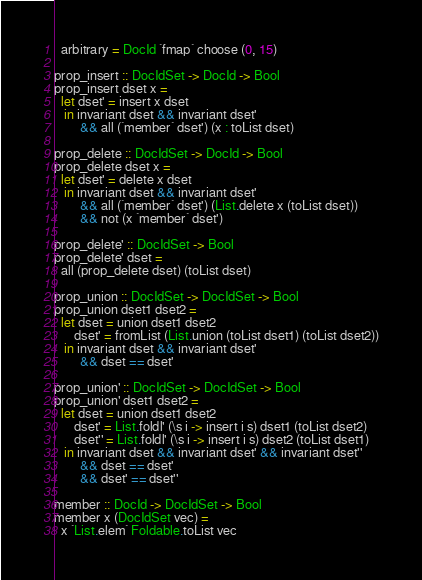<code> <loc_0><loc_0><loc_500><loc_500><_Haskell_>  arbitrary = DocId `fmap` choose (0, 15)

prop_insert :: DocIdSet -> DocId -> Bool
prop_insert dset x =
  let dset' = insert x dset
   in invariant dset && invariant dset'
        && all (`member` dset') (x : toList dset)

prop_delete :: DocIdSet -> DocId -> Bool
prop_delete dset x =
  let dset' = delete x dset
   in invariant dset && invariant dset'
        && all (`member` dset') (List.delete x (toList dset))
        && not (x `member` dset')

prop_delete' :: DocIdSet -> Bool
prop_delete' dset =
  all (prop_delete dset) (toList dset)

prop_union :: DocIdSet -> DocIdSet -> Bool
prop_union dset1 dset2 =
  let dset = union dset1 dset2
      dset' = fromList (List.union (toList dset1) (toList dset2))
   in invariant dset && invariant dset'
        && dset == dset'

prop_union' :: DocIdSet -> DocIdSet -> Bool
prop_union' dset1 dset2 =
  let dset = union dset1 dset2
      dset' = List.foldl' (\s i -> insert i s) dset1 (toList dset2)
      dset'' = List.foldl' (\s i -> insert i s) dset2 (toList dset1)
   in invariant dset && invariant dset' && invariant dset''
        && dset == dset'
        && dset' == dset''

member :: DocId -> DocIdSet -> Bool
member x (DocIdSet vec) =
  x `List.elem` Foldable.toList vec
</code> 